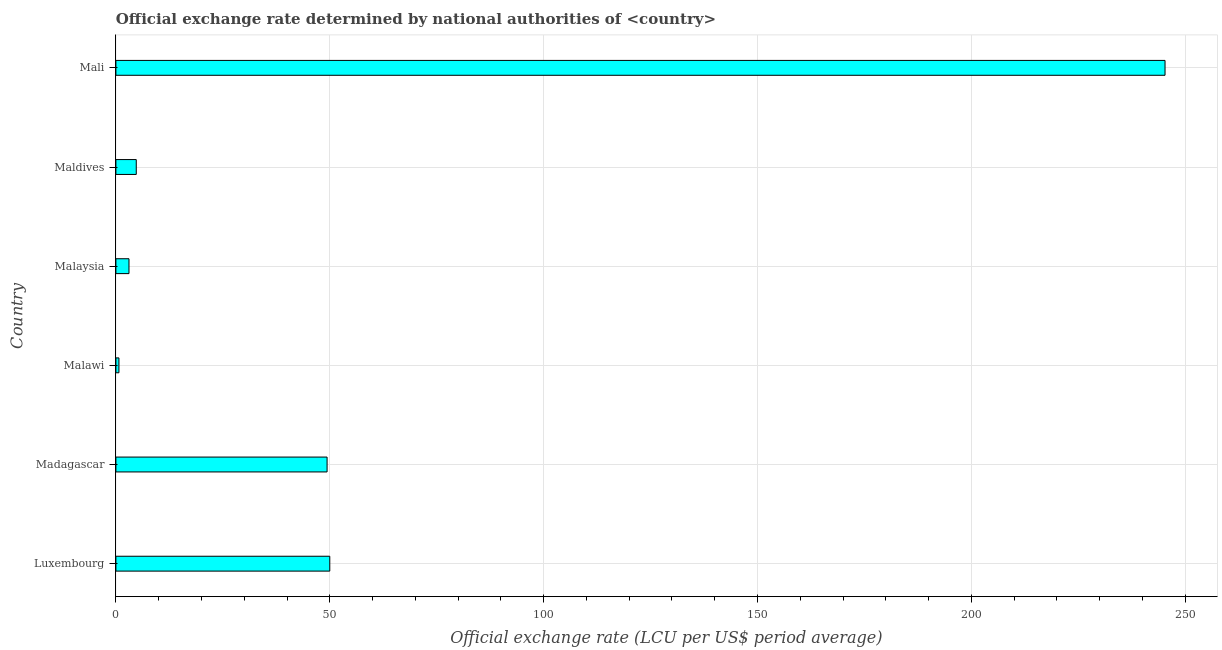Does the graph contain grids?
Give a very brief answer. Yes. What is the title of the graph?
Give a very brief answer. Official exchange rate determined by national authorities of <country>. What is the label or title of the X-axis?
Offer a terse response. Official exchange rate (LCU per US$ period average). What is the label or title of the Y-axis?
Your answer should be compact. Country. What is the official exchange rate in Madagascar?
Your answer should be very brief. 49.37. Across all countries, what is the maximum official exchange rate?
Provide a short and direct response. 245.26. Across all countries, what is the minimum official exchange rate?
Provide a short and direct response. 0.71. In which country was the official exchange rate maximum?
Offer a very short reply. Mali. In which country was the official exchange rate minimum?
Provide a succinct answer. Malawi. What is the sum of the official exchange rate?
Keep it short and to the point. 353.17. What is the difference between the official exchange rate in Maldives and Mali?
Make the answer very short. -240.5. What is the average official exchange rate per country?
Provide a succinct answer. 58.86. What is the median official exchange rate?
Keep it short and to the point. 27.07. In how many countries, is the official exchange rate greater than 130 ?
Offer a very short reply. 1. What is the ratio of the official exchange rate in Luxembourg to that in Mali?
Your answer should be compact. 0.2. What is the difference between the highest and the second highest official exchange rate?
Offer a terse response. 195.26. Is the sum of the official exchange rate in Luxembourg and Malawi greater than the maximum official exchange rate across all countries?
Give a very brief answer. No. What is the difference between the highest and the lowest official exchange rate?
Ensure brevity in your answer.  244.55. In how many countries, is the official exchange rate greater than the average official exchange rate taken over all countries?
Give a very brief answer. 1. How many countries are there in the graph?
Your response must be concise. 6. What is the Official exchange rate (LCU per US$ period average) of Luxembourg?
Keep it short and to the point. 50. What is the Official exchange rate (LCU per US$ period average) in Madagascar?
Provide a short and direct response. 49.37. What is the Official exchange rate (LCU per US$ period average) in Malawi?
Your response must be concise. 0.71. What is the Official exchange rate (LCU per US$ period average) of Malaysia?
Your response must be concise. 3.06. What is the Official exchange rate (LCU per US$ period average) in Maldives?
Give a very brief answer. 4.76. What is the Official exchange rate (LCU per US$ period average) of Mali?
Ensure brevity in your answer.  245.26. What is the difference between the Official exchange rate (LCU per US$ period average) in Luxembourg and Madagascar?
Make the answer very short. 0.63. What is the difference between the Official exchange rate (LCU per US$ period average) in Luxembourg and Malawi?
Make the answer very short. 49.29. What is the difference between the Official exchange rate (LCU per US$ period average) in Luxembourg and Malaysia?
Give a very brief answer. 46.94. What is the difference between the Official exchange rate (LCU per US$ period average) in Luxembourg and Maldives?
Provide a succinct answer. 45.24. What is the difference between the Official exchange rate (LCU per US$ period average) in Luxembourg and Mali?
Provide a succinct answer. -195.26. What is the difference between the Official exchange rate (LCU per US$ period average) in Madagascar and Malawi?
Your answer should be compact. 48.66. What is the difference between the Official exchange rate (LCU per US$ period average) in Madagascar and Malaysia?
Give a very brief answer. 46.31. What is the difference between the Official exchange rate (LCU per US$ period average) in Madagascar and Maldives?
Offer a terse response. 44.61. What is the difference between the Official exchange rate (LCU per US$ period average) in Madagascar and Mali?
Ensure brevity in your answer.  -195.89. What is the difference between the Official exchange rate (LCU per US$ period average) in Malawi and Malaysia?
Your response must be concise. -2.35. What is the difference between the Official exchange rate (LCU per US$ period average) in Malawi and Maldives?
Ensure brevity in your answer.  -4.05. What is the difference between the Official exchange rate (LCU per US$ period average) in Malawi and Mali?
Offer a terse response. -244.55. What is the difference between the Official exchange rate (LCU per US$ period average) in Malaysia and Maldives?
Keep it short and to the point. -1.7. What is the difference between the Official exchange rate (LCU per US$ period average) in Malaysia and Mali?
Offer a very short reply. -242.2. What is the difference between the Official exchange rate (LCU per US$ period average) in Maldives and Mali?
Your answer should be very brief. -240.5. What is the ratio of the Official exchange rate (LCU per US$ period average) in Luxembourg to that in Madagascar?
Offer a very short reply. 1.01. What is the ratio of the Official exchange rate (LCU per US$ period average) in Luxembourg to that in Malaysia?
Offer a terse response. 16.33. What is the ratio of the Official exchange rate (LCU per US$ period average) in Luxembourg to that in Maldives?
Give a very brief answer. 10.5. What is the ratio of the Official exchange rate (LCU per US$ period average) in Luxembourg to that in Mali?
Provide a succinct answer. 0.2. What is the ratio of the Official exchange rate (LCU per US$ period average) in Madagascar to that in Malawi?
Provide a succinct answer. 69.12. What is the ratio of the Official exchange rate (LCU per US$ period average) in Madagascar to that in Malaysia?
Provide a succinct answer. 16.13. What is the ratio of the Official exchange rate (LCU per US$ period average) in Madagascar to that in Maldives?
Provide a succinct answer. 10.37. What is the ratio of the Official exchange rate (LCU per US$ period average) in Madagascar to that in Mali?
Your answer should be very brief. 0.2. What is the ratio of the Official exchange rate (LCU per US$ period average) in Malawi to that in Malaysia?
Ensure brevity in your answer.  0.23. What is the ratio of the Official exchange rate (LCU per US$ period average) in Malawi to that in Mali?
Ensure brevity in your answer.  0. What is the ratio of the Official exchange rate (LCU per US$ period average) in Malaysia to that in Maldives?
Keep it short and to the point. 0.64. What is the ratio of the Official exchange rate (LCU per US$ period average) in Malaysia to that in Mali?
Make the answer very short. 0.01. What is the ratio of the Official exchange rate (LCU per US$ period average) in Maldives to that in Mali?
Give a very brief answer. 0.02. 